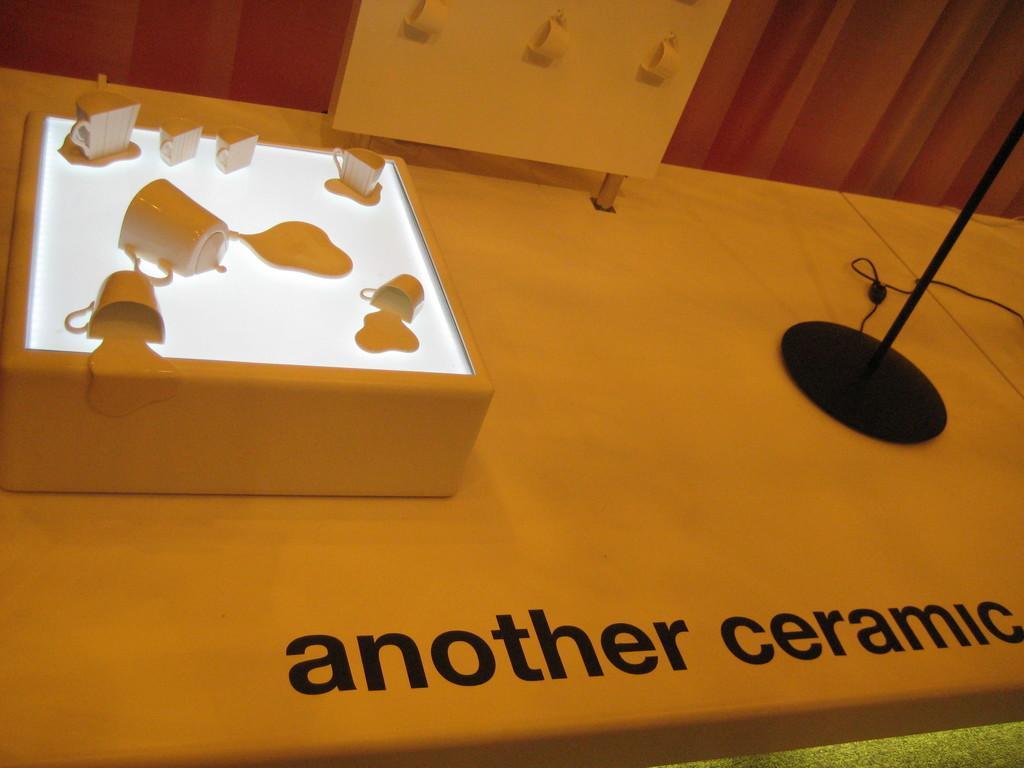In one or two sentences, can you explain what this image depicts? In this image we can see objects, stand, cable and cups hanging on a board are on the platform. We can see a text written on the platform. In the background we can see the wall. 